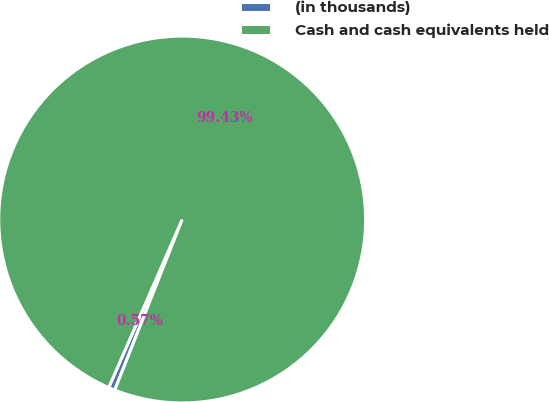Convert chart. <chart><loc_0><loc_0><loc_500><loc_500><pie_chart><fcel>(in thousands)<fcel>Cash and cash equivalents held<nl><fcel>0.57%<fcel>99.43%<nl></chart> 